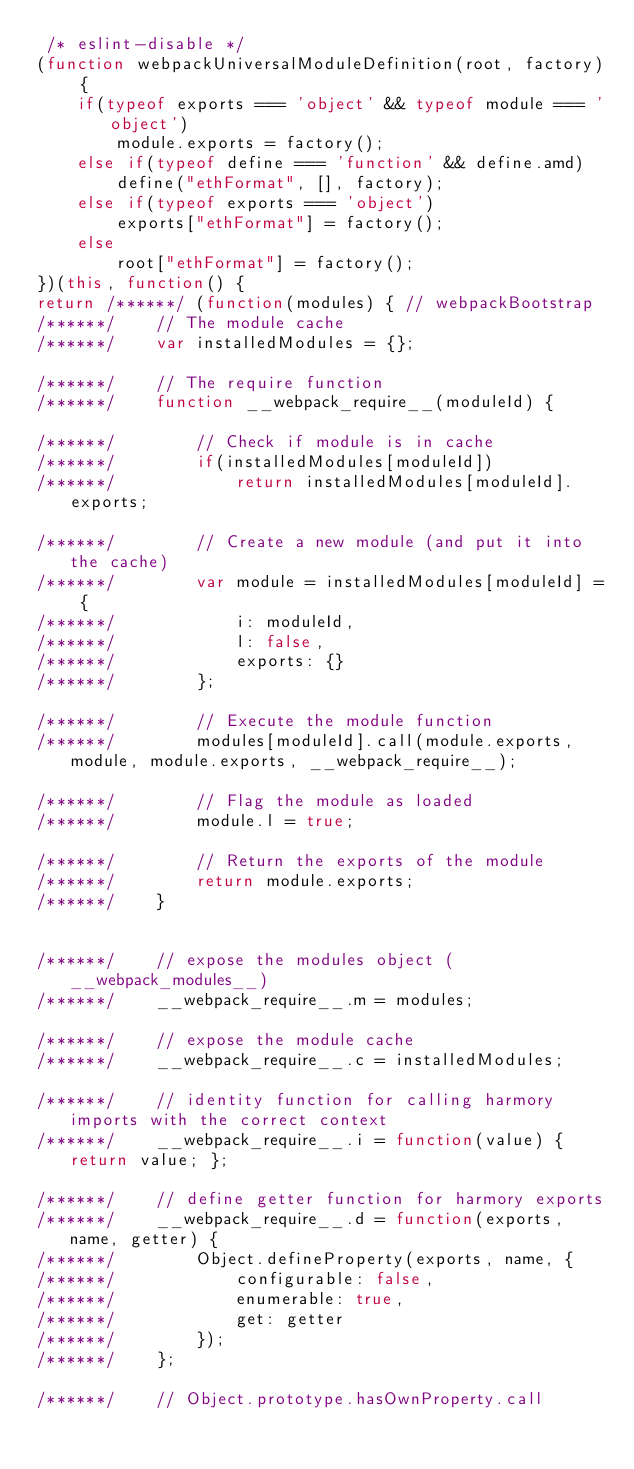<code> <loc_0><loc_0><loc_500><loc_500><_JavaScript_> /* eslint-disable */ 
(function webpackUniversalModuleDefinition(root, factory) {
	if(typeof exports === 'object' && typeof module === 'object')
		module.exports = factory();
	else if(typeof define === 'function' && define.amd)
		define("ethFormat", [], factory);
	else if(typeof exports === 'object')
		exports["ethFormat"] = factory();
	else
		root["ethFormat"] = factory();
})(this, function() {
return /******/ (function(modules) { // webpackBootstrap
/******/ 	// The module cache
/******/ 	var installedModules = {};

/******/ 	// The require function
/******/ 	function __webpack_require__(moduleId) {

/******/ 		// Check if module is in cache
/******/ 		if(installedModules[moduleId])
/******/ 			return installedModules[moduleId].exports;

/******/ 		// Create a new module (and put it into the cache)
/******/ 		var module = installedModules[moduleId] = {
/******/ 			i: moduleId,
/******/ 			l: false,
/******/ 			exports: {}
/******/ 		};

/******/ 		// Execute the module function
/******/ 		modules[moduleId].call(module.exports, module, module.exports, __webpack_require__);

/******/ 		// Flag the module as loaded
/******/ 		module.l = true;

/******/ 		// Return the exports of the module
/******/ 		return module.exports;
/******/ 	}


/******/ 	// expose the modules object (__webpack_modules__)
/******/ 	__webpack_require__.m = modules;

/******/ 	// expose the module cache
/******/ 	__webpack_require__.c = installedModules;

/******/ 	// identity function for calling harmory imports with the correct context
/******/ 	__webpack_require__.i = function(value) { return value; };

/******/ 	// define getter function for harmory exports
/******/ 	__webpack_require__.d = function(exports, name, getter) {
/******/ 		Object.defineProperty(exports, name, {
/******/ 			configurable: false,
/******/ 			enumerable: true,
/******/ 			get: getter
/******/ 		});
/******/ 	};

/******/ 	// Object.prototype.hasOwnProperty.call</code> 